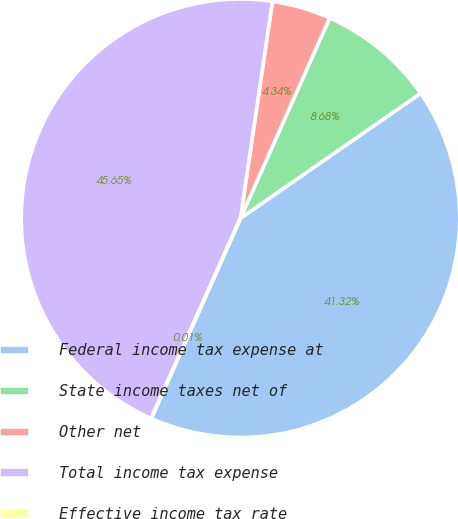Convert chart to OTSL. <chart><loc_0><loc_0><loc_500><loc_500><pie_chart><fcel>Federal income tax expense at<fcel>State income taxes net of<fcel>Other net<fcel>Total income tax expense<fcel>Effective income tax rate<nl><fcel>41.32%<fcel>8.68%<fcel>4.34%<fcel>45.65%<fcel>0.01%<nl></chart> 